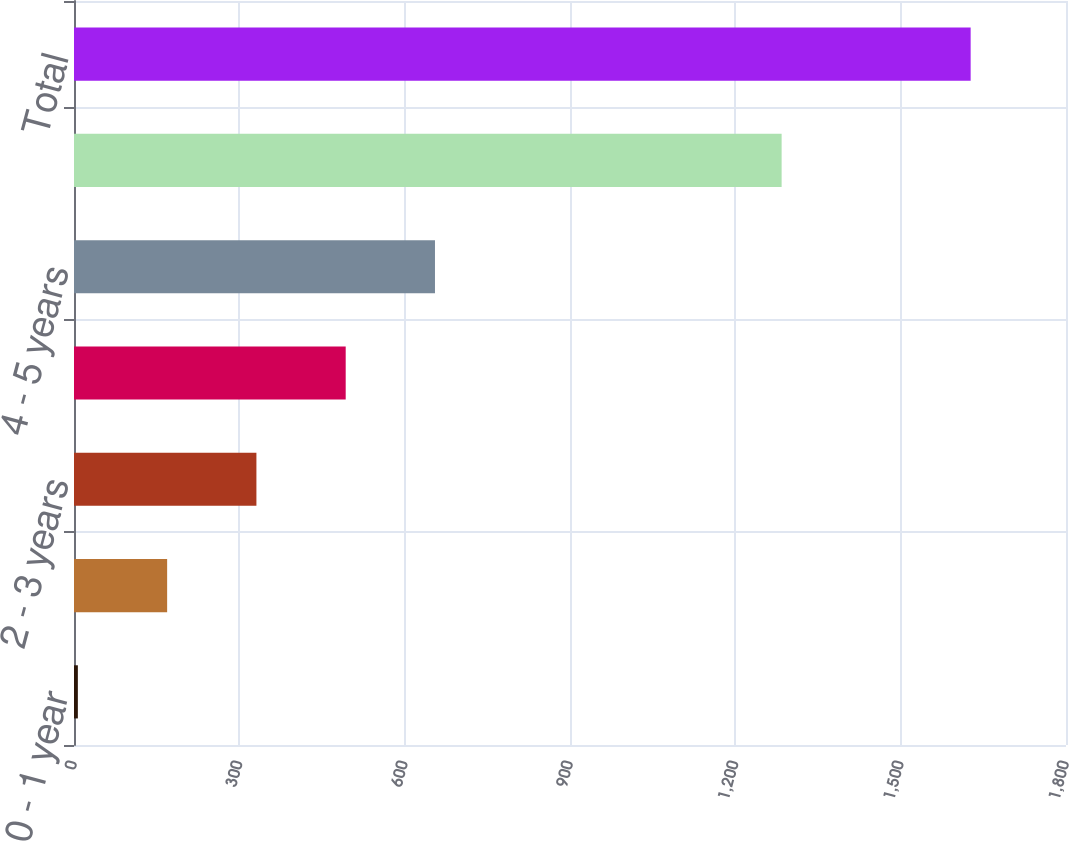Convert chart to OTSL. <chart><loc_0><loc_0><loc_500><loc_500><bar_chart><fcel>0 - 1 year<fcel>1 - 2 years<fcel>2 - 3 years<fcel>3 - 4 years<fcel>4 - 5 years<fcel>Thereafter<fcel>Total<nl><fcel>7<fcel>169<fcel>331<fcel>493<fcel>655<fcel>1284<fcel>1627<nl></chart> 